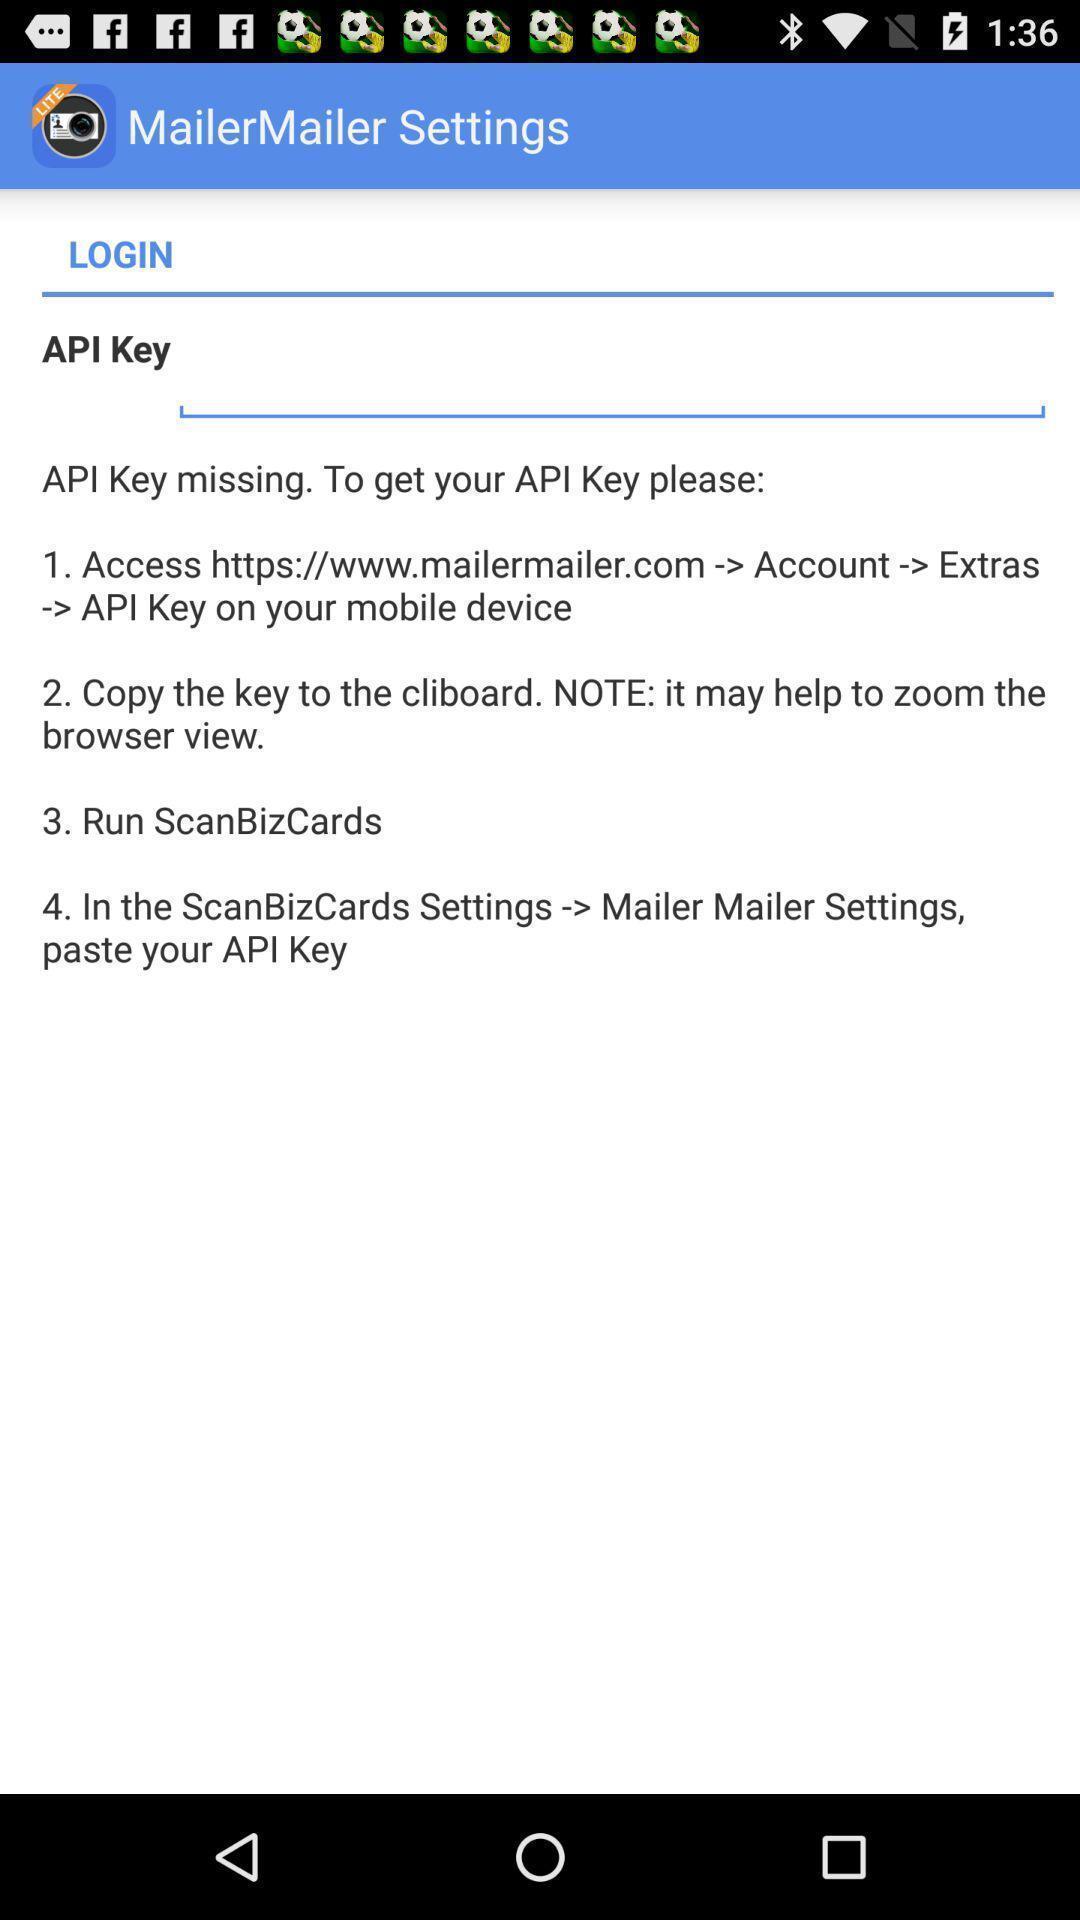Give me a narrative description of this picture. Screen displaying settings. 